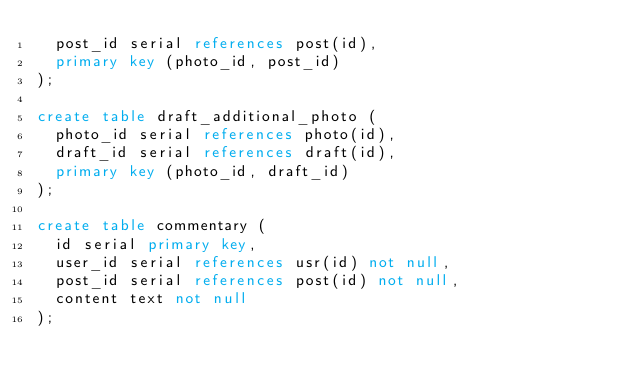Convert code to text. <code><loc_0><loc_0><loc_500><loc_500><_SQL_>  post_id serial references post(id),
  primary key (photo_id, post_id)
);

create table draft_additional_photo (
  photo_id serial references photo(id),
  draft_id serial references draft(id),
  primary key (photo_id, draft_id)
);

create table commentary (
  id serial primary key,
  user_id serial references usr(id) not null,
  post_id serial references post(id) not null,
  content text not null
);
</code> 